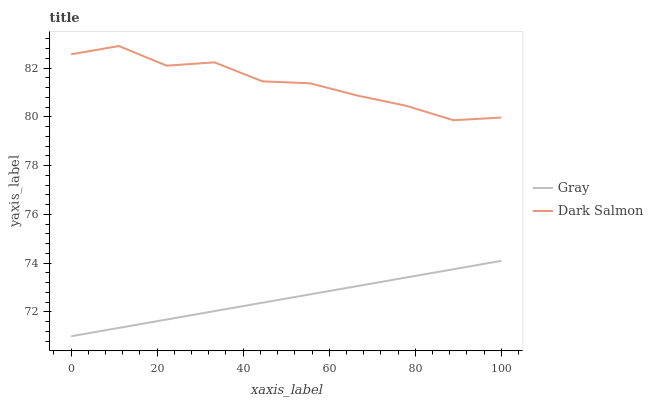Does Gray have the minimum area under the curve?
Answer yes or no. Yes. Does Dark Salmon have the maximum area under the curve?
Answer yes or no. Yes. Does Dark Salmon have the minimum area under the curve?
Answer yes or no. No. Is Gray the smoothest?
Answer yes or no. Yes. Is Dark Salmon the roughest?
Answer yes or no. Yes. Is Dark Salmon the smoothest?
Answer yes or no. No. Does Gray have the lowest value?
Answer yes or no. Yes. Does Dark Salmon have the lowest value?
Answer yes or no. No. Does Dark Salmon have the highest value?
Answer yes or no. Yes. Is Gray less than Dark Salmon?
Answer yes or no. Yes. Is Dark Salmon greater than Gray?
Answer yes or no. Yes. Does Gray intersect Dark Salmon?
Answer yes or no. No. 